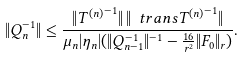<formula> <loc_0><loc_0><loc_500><loc_500>\| Q _ { n } ^ { - 1 } \| \leq \frac { \| { T ^ { ( n ) } } ^ { - 1 } \| \, \| \ t r a n s { T ^ { ( n ) } } ^ { - 1 } \| } { \mu _ { n } | \eta _ { n } | ( \| Q _ { n - 1 } ^ { - 1 } \| ^ { - 1 } - \frac { 1 6 } { r ^ { 2 } } \| F _ { 0 } \| _ { r } ) } .</formula> 